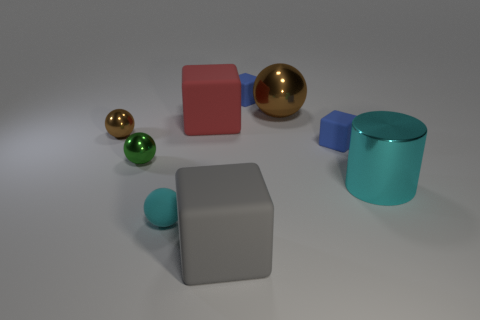How many cubes are the same color as the large metallic cylinder?
Give a very brief answer. 0. Does the green shiny ball have the same size as the sphere that is in front of the cyan metallic cylinder?
Your answer should be compact. Yes. What is the size of the blue cube behind the big block that is on the left side of the block in front of the tiny cyan matte sphere?
Keep it short and to the point. Small. There is a tiny green ball; what number of large metal cylinders are on the left side of it?
Your answer should be compact. 0. The brown ball that is left of the metallic sphere that is in front of the tiny brown shiny ball is made of what material?
Provide a short and direct response. Metal. Are there any other things that are the same size as the gray matte thing?
Keep it short and to the point. Yes. Do the red rubber block and the gray cube have the same size?
Offer a very short reply. Yes. How many things are rubber blocks that are to the left of the gray matte object or matte cubes in front of the big shiny ball?
Offer a terse response. 3. Is the number of gray cubes that are behind the small cyan rubber ball greater than the number of red rubber cubes?
Your response must be concise. No. How many other things are there of the same shape as the big red thing?
Offer a terse response. 3. 